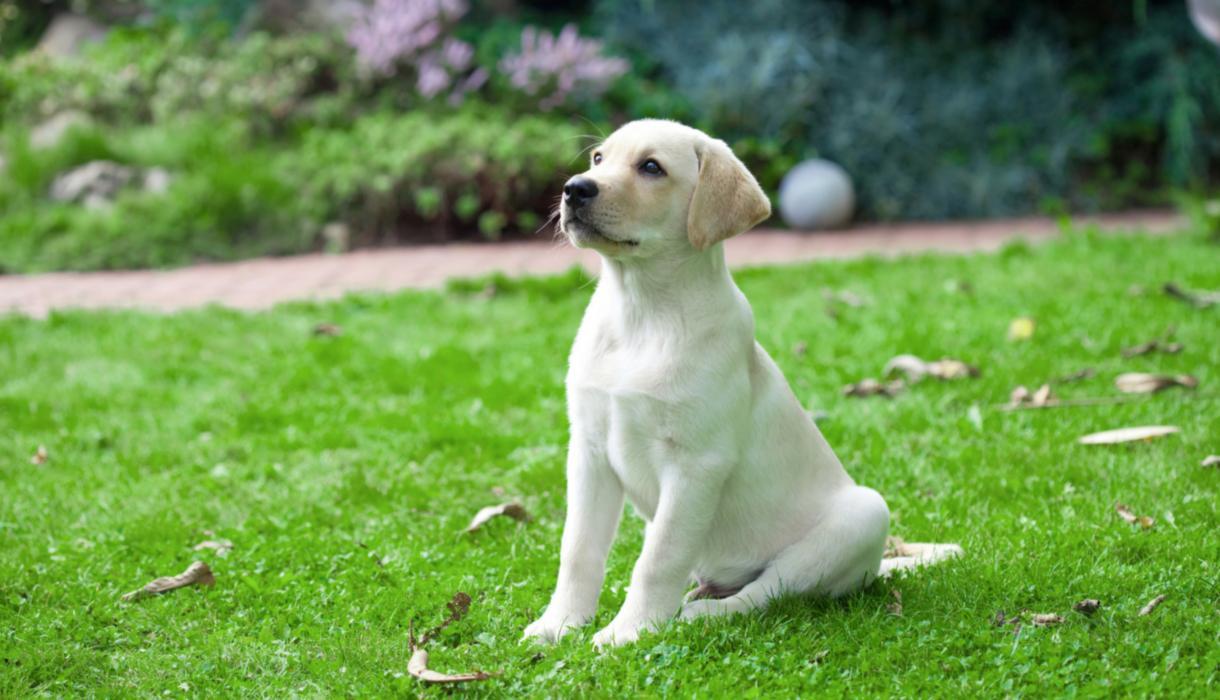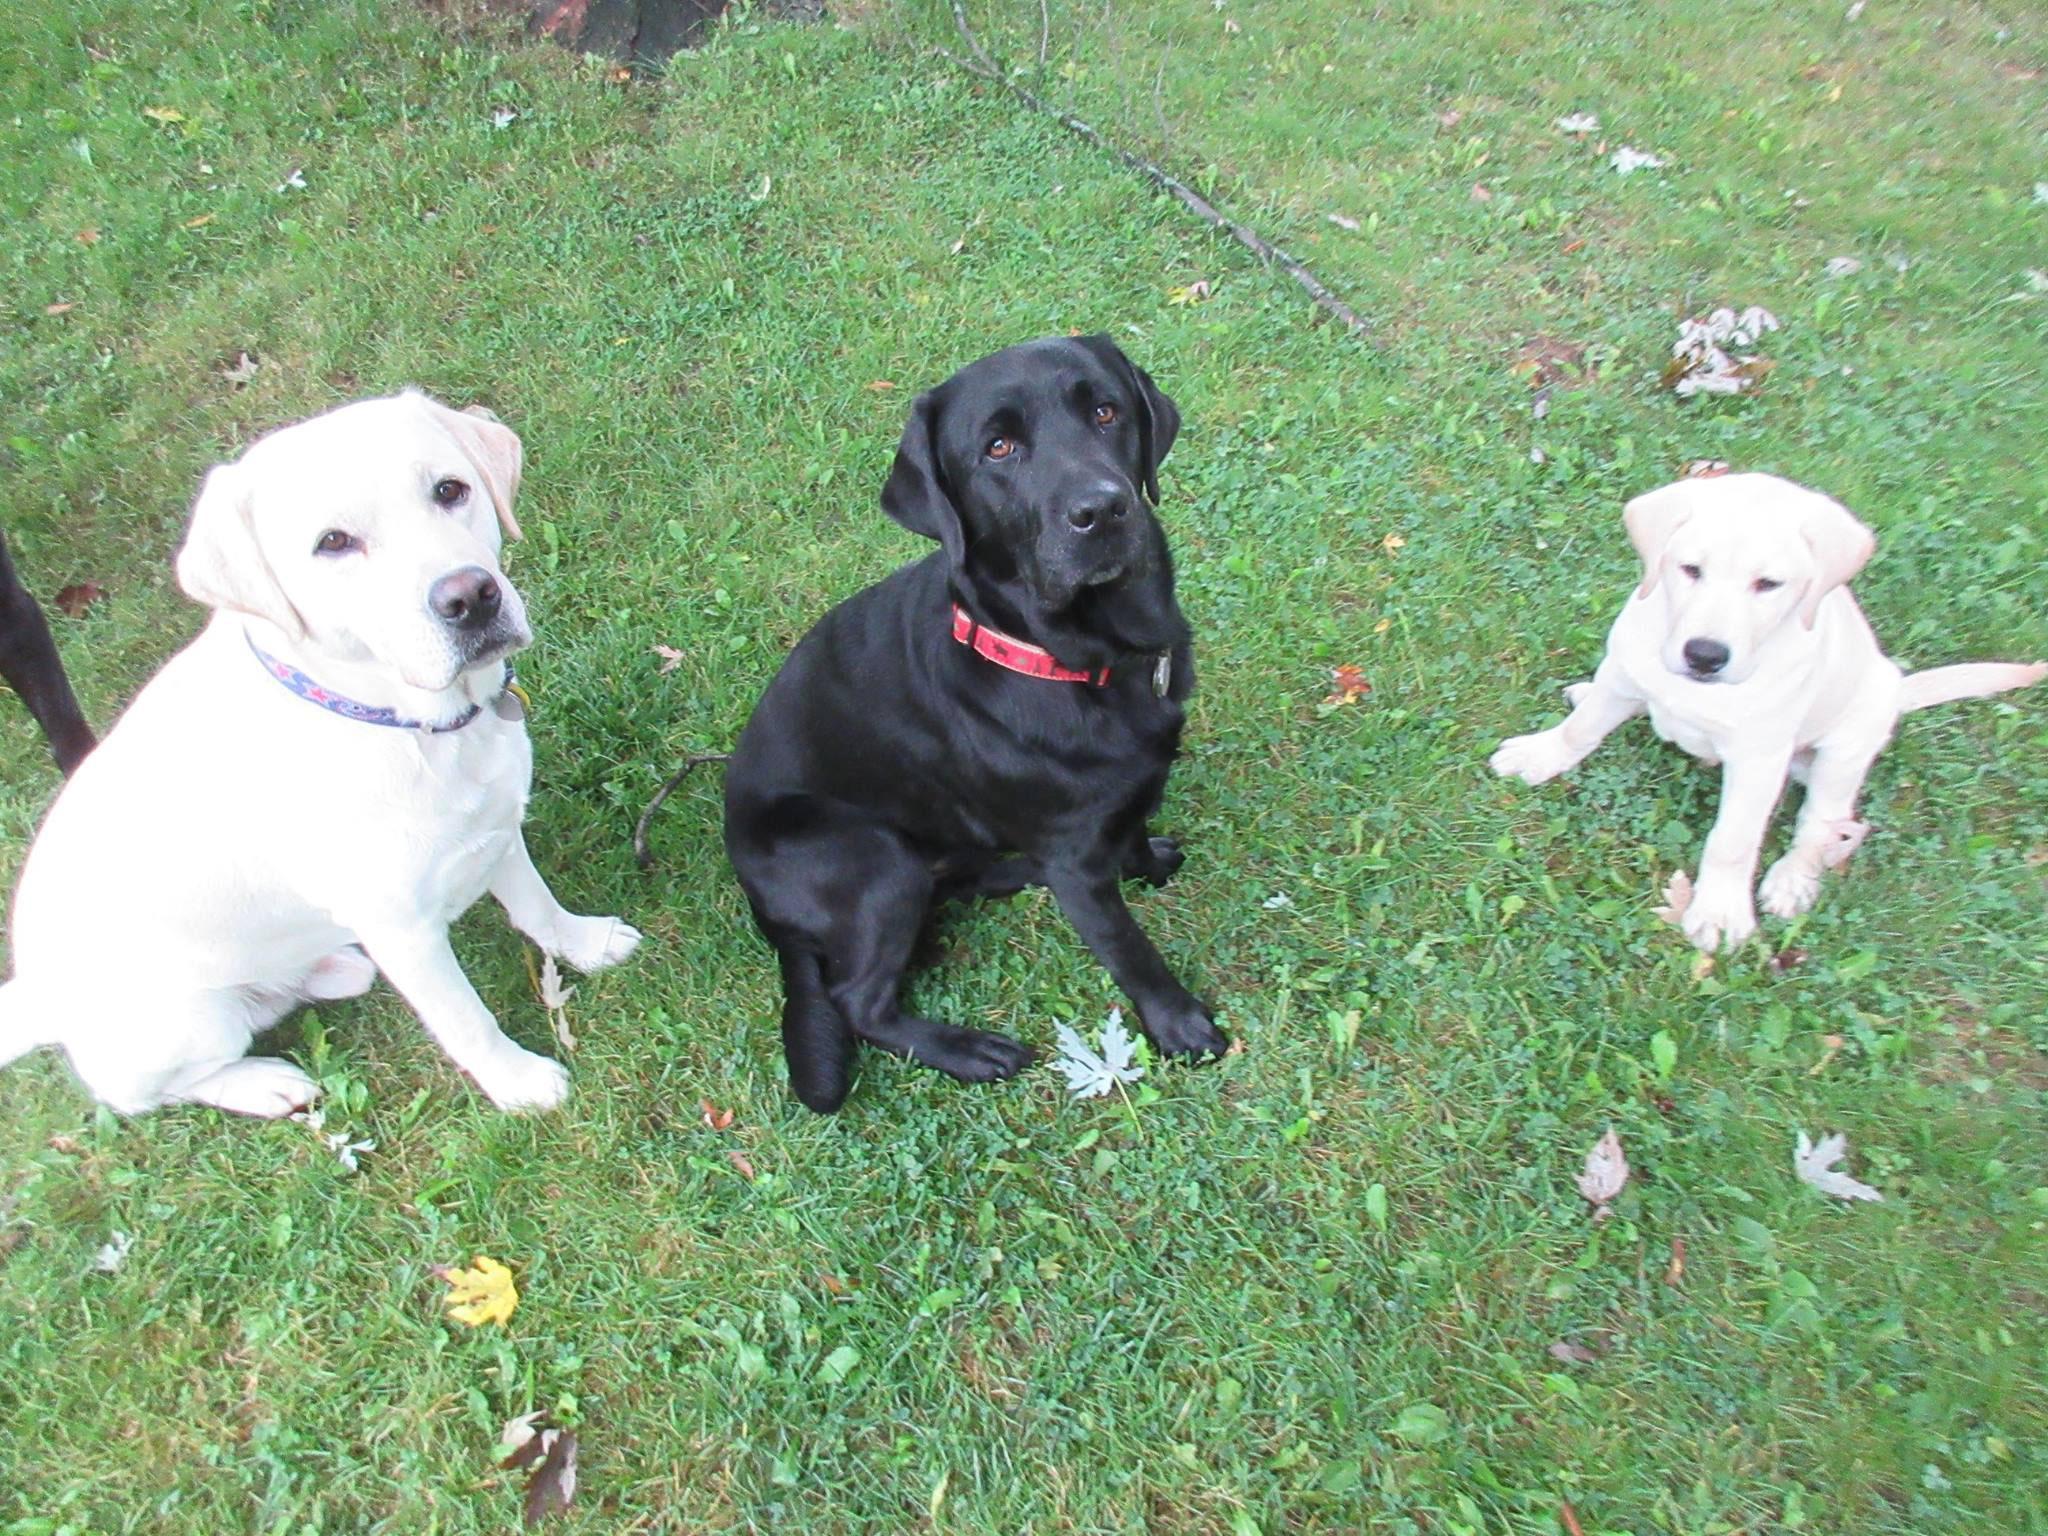The first image is the image on the left, the second image is the image on the right. Considering the images on both sides, is "One of the dogs is missing a front leg." valid? Answer yes or no. No. The first image is the image on the left, the second image is the image on the right. Analyze the images presented: Is the assertion "One image features one dog that is missing a front limb, and the other image contains at least twice as many dogs." valid? Answer yes or no. No. 